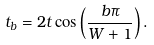Convert formula to latex. <formula><loc_0><loc_0><loc_500><loc_500>t _ { b } = 2 t \cos \left ( \frac { b \pi } { W + 1 } \right ) .</formula> 